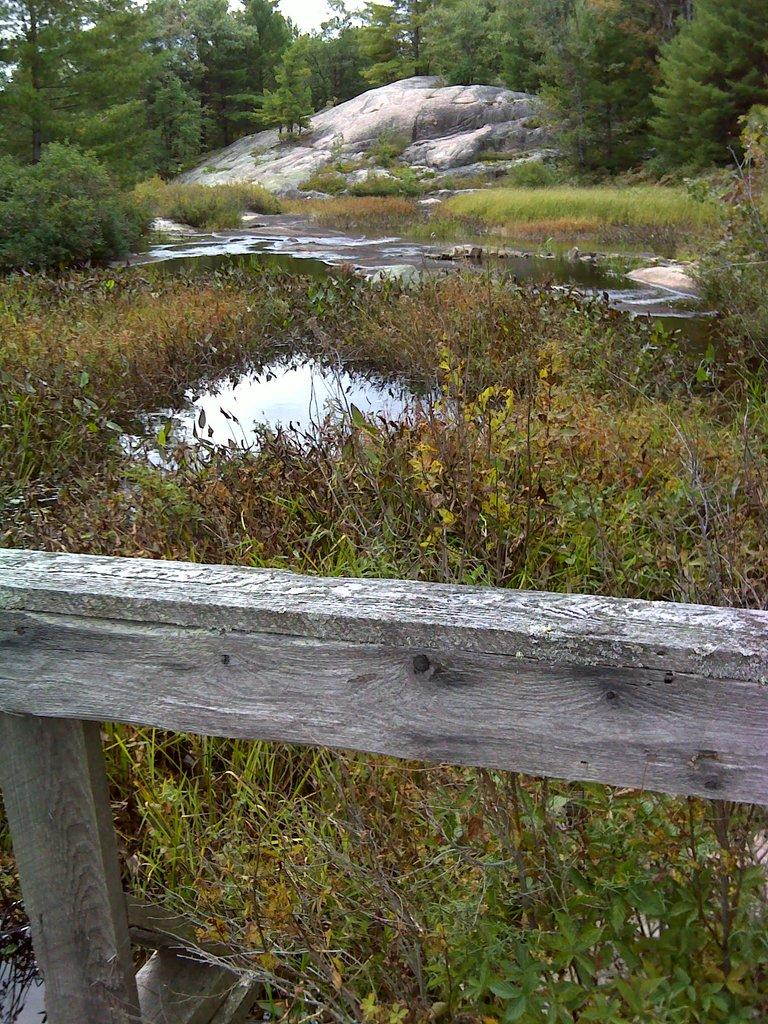What type of natural elements can be seen in the image? There are trees and water visible in the image. What other objects can be seen in the image? There is a rock, plants, and a wooden fence in the image. Can you describe the plane flying over the trees in the image? There is no plane visible in the image; it only features trees, water, a rock, plants, and a wooden fence. 